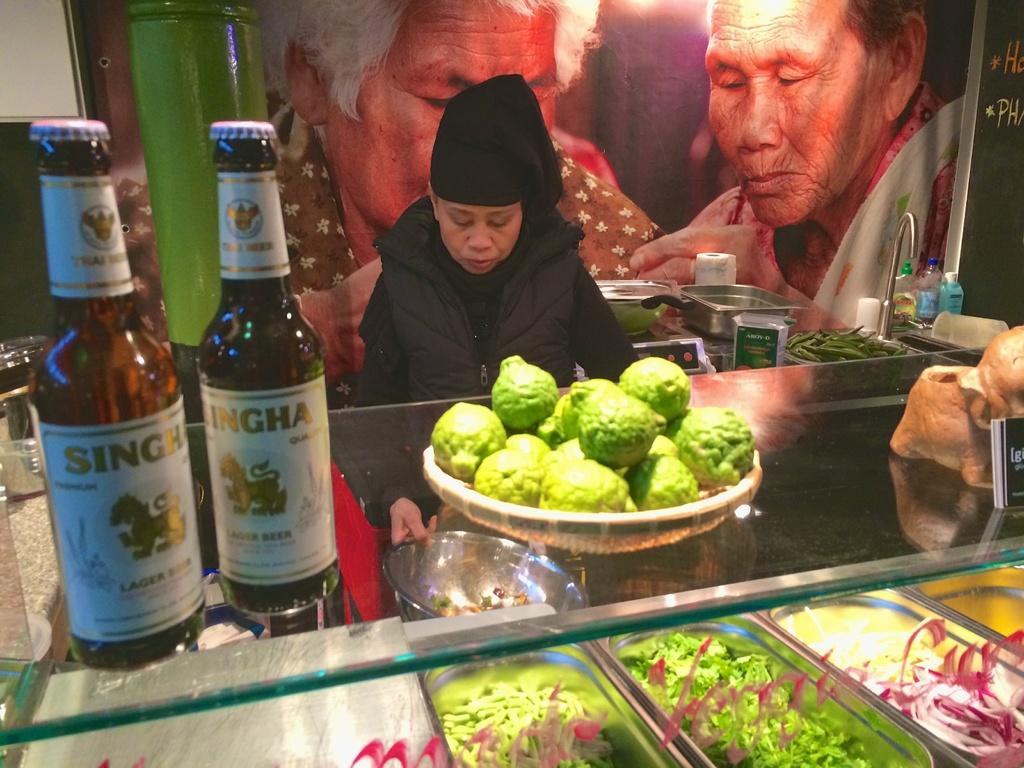How would you summarize this image in a sentence or two? A lady wearing a black jacket and a cap is holding a plate and in front of her there is a table. On the table there are tray with fruits, bottles. Inside the table there are many food items on different vessels. In the background there is a banner of two persons. Also there are bowls, vessels, vegetables, tap, bottles in the background. 